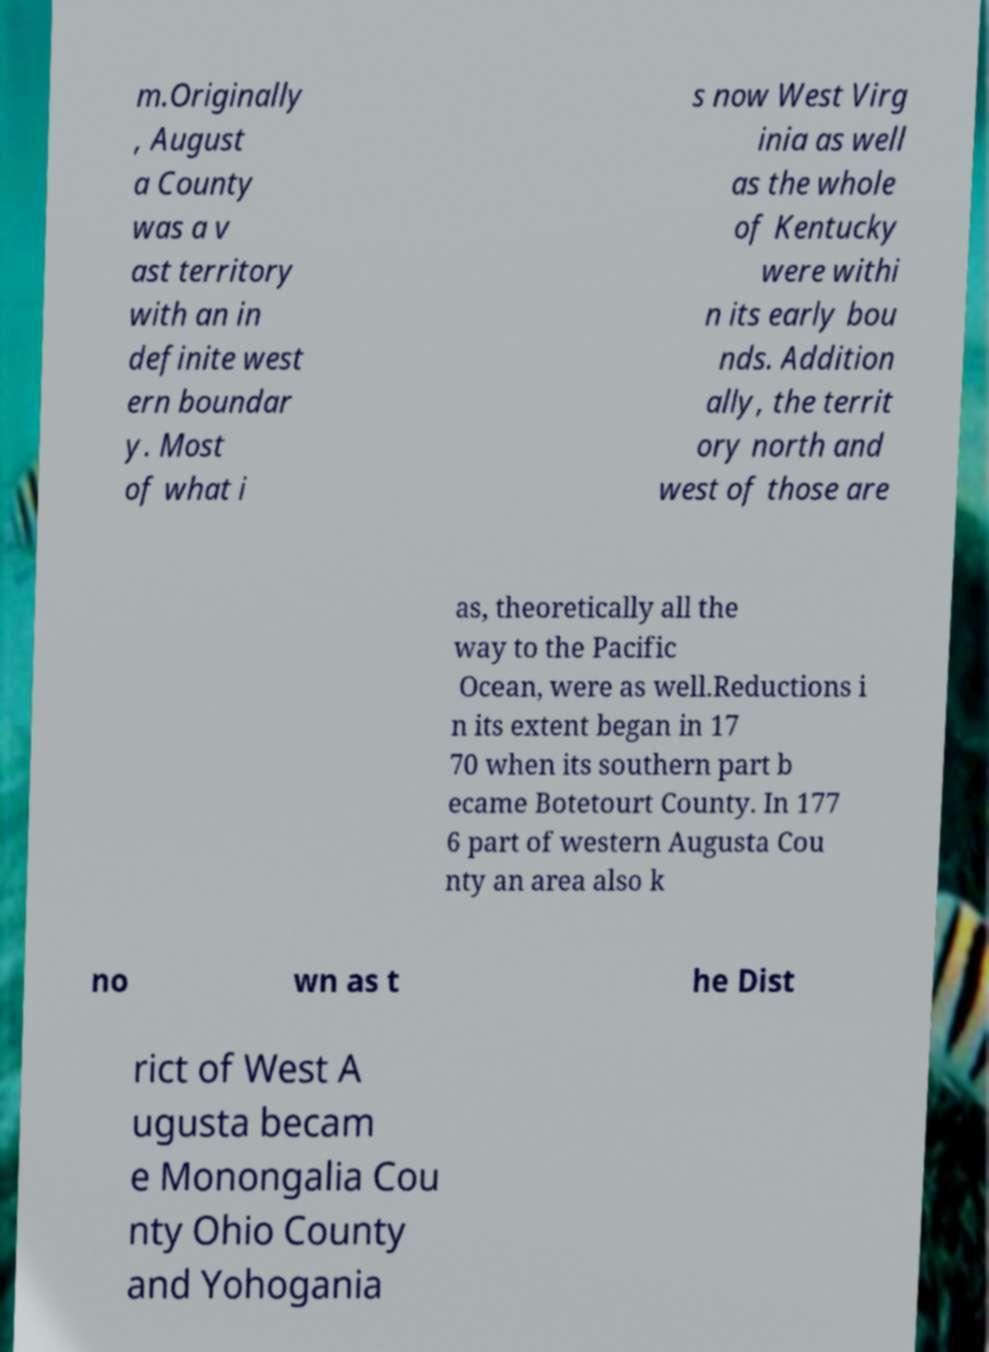Please read and relay the text visible in this image. What does it say? m.Originally , August a County was a v ast territory with an in definite west ern boundar y. Most of what i s now West Virg inia as well as the whole of Kentucky were withi n its early bou nds. Addition ally, the territ ory north and west of those are as, theoretically all the way to the Pacific Ocean, were as well.Reductions i n its extent began in 17 70 when its southern part b ecame Botetourt County. In 177 6 part of western Augusta Cou nty an area also k no wn as t he Dist rict of West A ugusta becam e Monongalia Cou nty Ohio County and Yohogania 